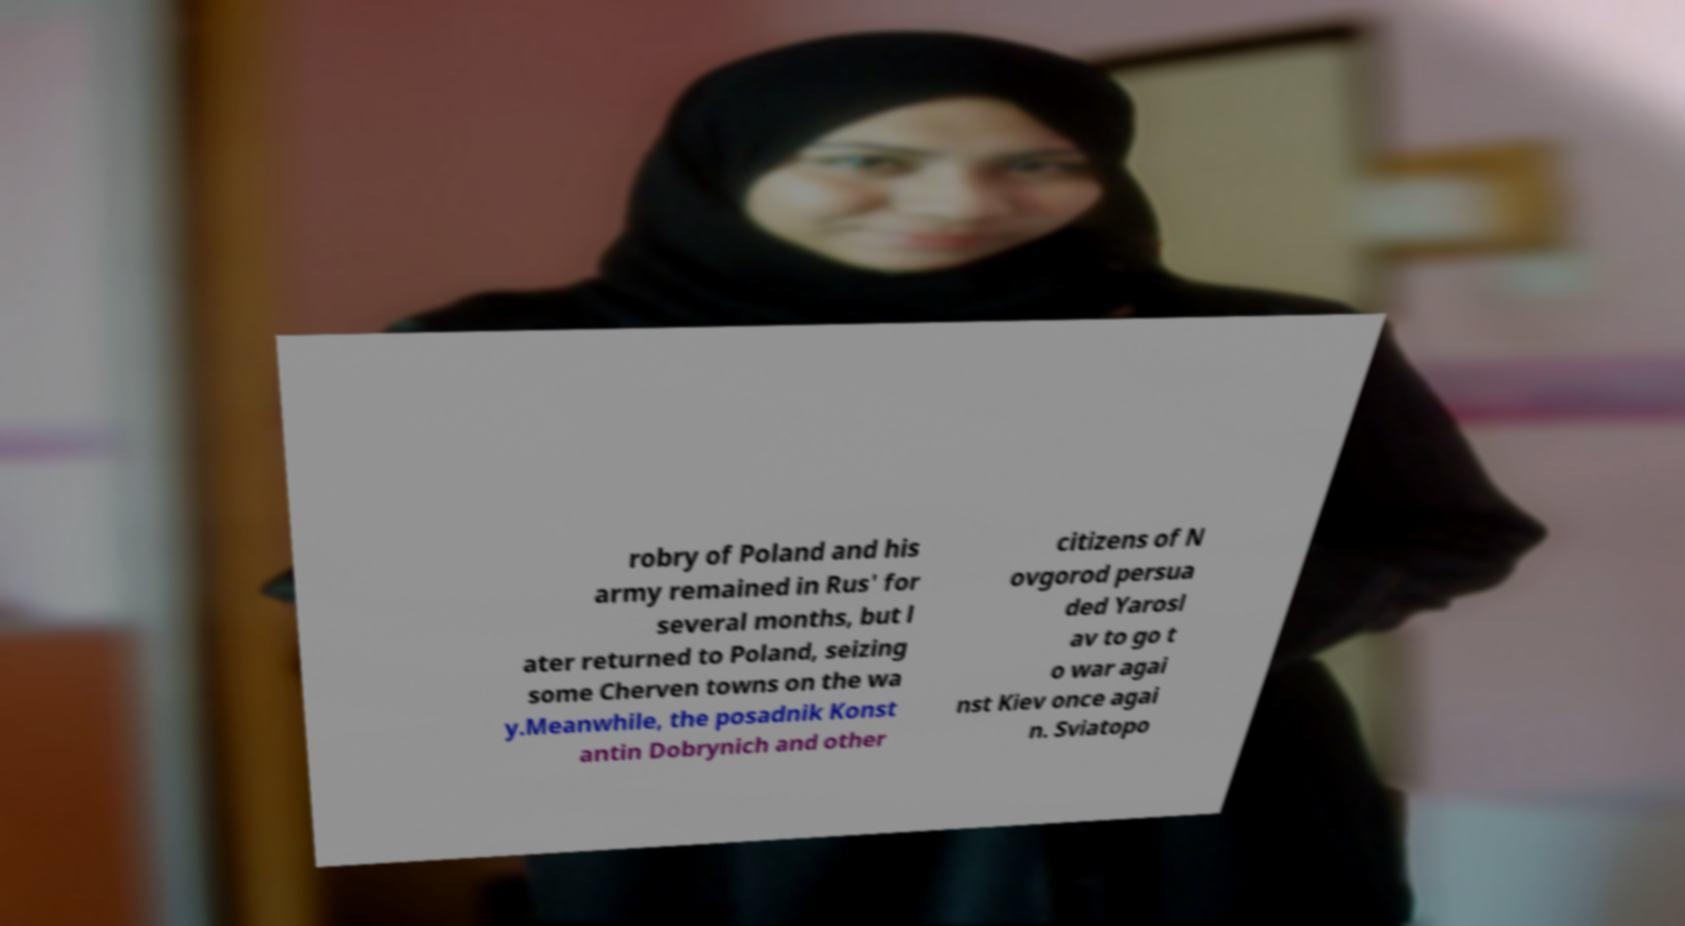Could you extract and type out the text from this image? robry of Poland and his army remained in Rus' for several months, but l ater returned to Poland, seizing some Cherven towns on the wa y.Meanwhile, the posadnik Konst antin Dobrynich and other citizens of N ovgorod persua ded Yarosl av to go t o war agai nst Kiev once agai n. Sviatopo 